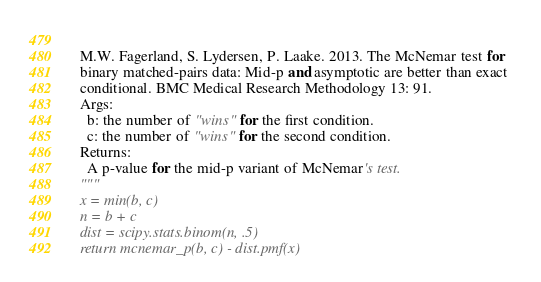Convert code to text. <code><loc_0><loc_0><loc_500><loc_500><_Python_>    
  M.W. Fagerland, S. Lydersen, P. Laake. 2013. The McNemar test for 
  binary matched-pairs data: Mid-p and asymptotic are better than exact 
  conditional. BMC Medical Research Methodology 13: 91.
  Args:
    b: the number of "wins" for the first condition.
    c: the number of "wins" for the second condition.
  Returns:
    A p-value for the mid-p variant of McNemar's test.
  """
  x = min(b, c)
  n = b + c
  dist = scipy.stats.binom(n, .5)
  return mcnemar_p(b, c) - dist.pmf(x)</code> 